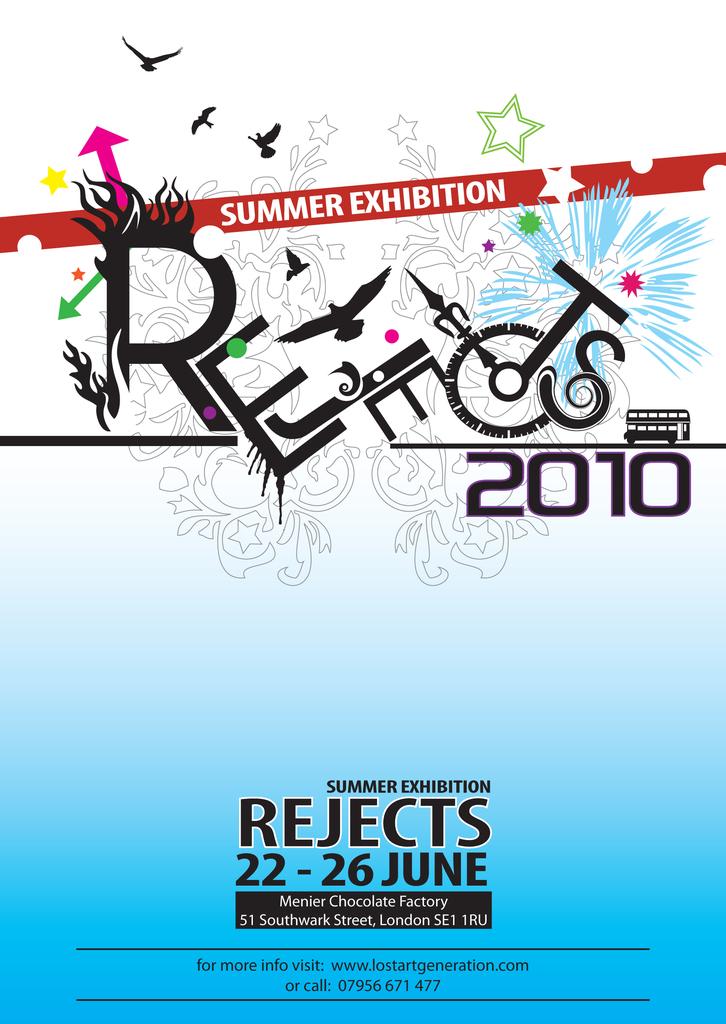What month is this exhibit open?
Give a very brief answer. June. 